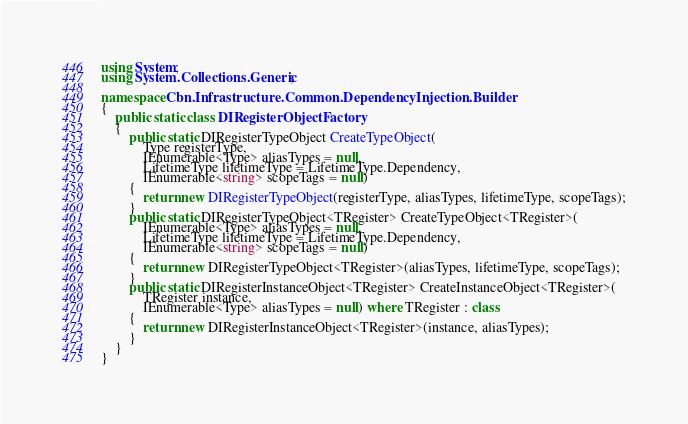<code> <loc_0><loc_0><loc_500><loc_500><_C#_>using System;
using System.Collections.Generic;

namespace Cbn.Infrastructure.Common.DependencyInjection.Builder
{
    public static class DIRegisterObjectFactory
    {
        public static DIRegisterTypeObject CreateTypeObject(
            Type registerType,
            IEnumerable<Type> aliasTypes = null,
            LifetimeType lifetimeType = LifetimeType.Dependency,
            IEnumerable<string> scopeTags = null)
        {
            return new DIRegisterTypeObject(registerType, aliasTypes, lifetimeType, scopeTags);
        }
        public static DIRegisterTypeObject<TRegister> CreateTypeObject<TRegister>(
            IEnumerable<Type> aliasTypes = null,
            LifetimeType lifetimeType = LifetimeType.Dependency,
            IEnumerable<string> scopeTags = null)
        {
            return new DIRegisterTypeObject<TRegister>(aliasTypes, lifetimeType, scopeTags);
        }
        public static DIRegisterInstanceObject<TRegister> CreateInstanceObject<TRegister>(
            TRegister instance,
            IEnumerable<Type> aliasTypes = null) where TRegister : class
        {
            return new DIRegisterInstanceObject<TRegister>(instance, aliasTypes);
        }
    }
}</code> 